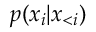<formula> <loc_0><loc_0><loc_500><loc_500>p ( x _ { i } | \boldsymbol x _ { < i } )</formula> 